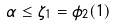<formula> <loc_0><loc_0><loc_500><loc_500>\alpha \leq \zeta _ { 1 } = \phi _ { 2 } ( 1 )</formula> 